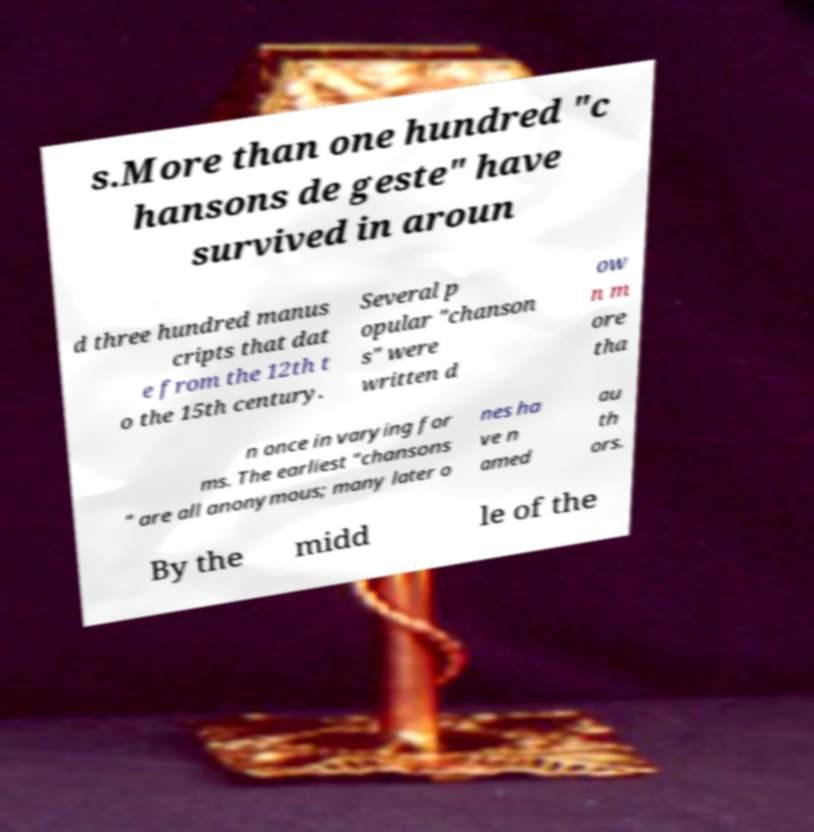I need the written content from this picture converted into text. Can you do that? s.More than one hundred "c hansons de geste" have survived in aroun d three hundred manus cripts that dat e from the 12th t o the 15th century. Several p opular "chanson s" were written d ow n m ore tha n once in varying for ms. The earliest "chansons " are all anonymous; many later o nes ha ve n amed au th ors. By the midd le of the 